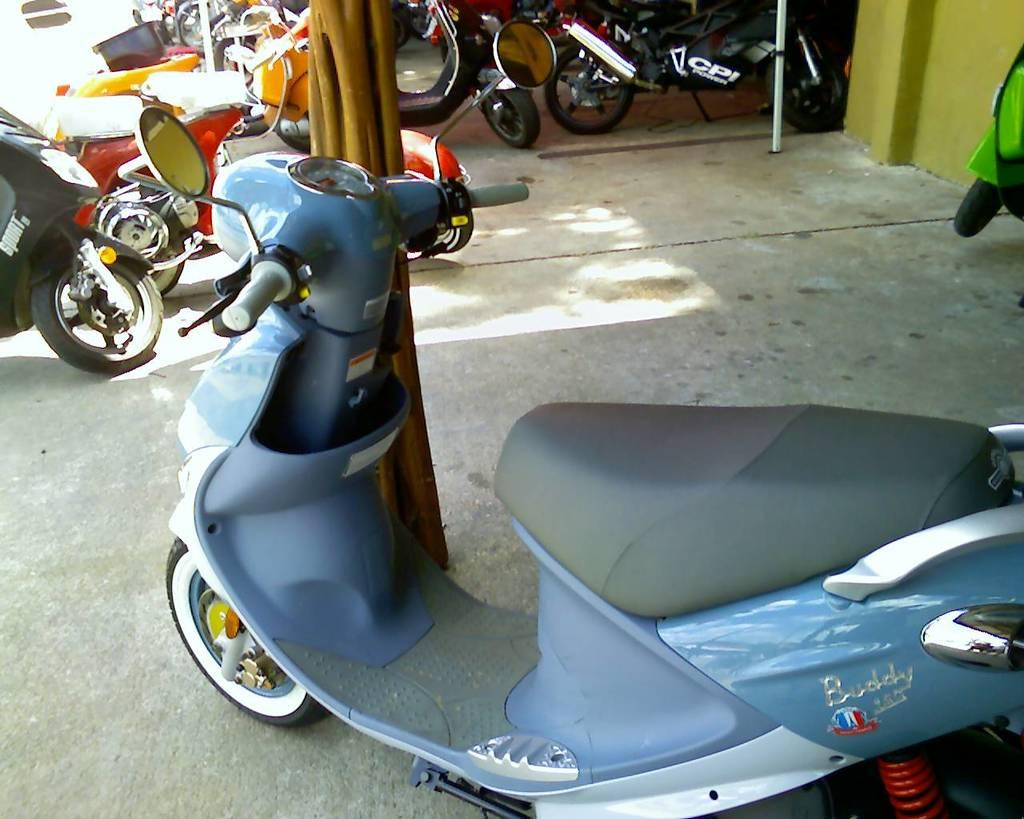What can be seen in the image in terms of transportation? There are multiple vehicles in the image. How are the vehicles arranged in the image? The vehicles are parked in one place. What is the purpose of the airport in the image? There is no airport present in the image; it only features parked vehicles. 